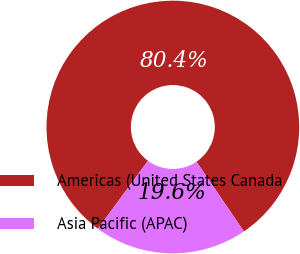<chart> <loc_0><loc_0><loc_500><loc_500><pie_chart><fcel>Americas (United States Canada<fcel>Asia Pacific (APAC)<nl><fcel>80.39%<fcel>19.61%<nl></chart> 